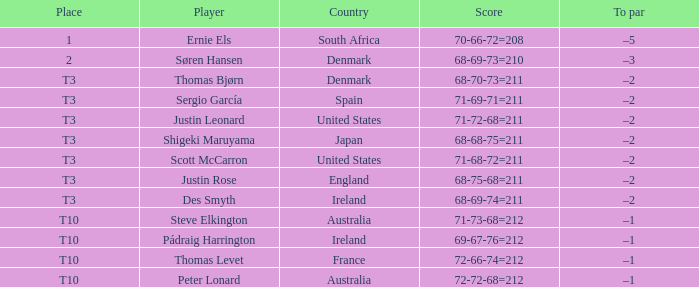What was the rank when the score was 71-69-71=211? T3. 